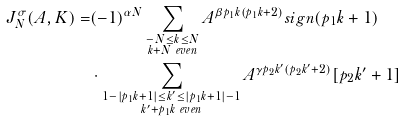Convert formula to latex. <formula><loc_0><loc_0><loc_500><loc_500>J _ { N } ^ { \sigma } ( A , K ) = & ( - 1 ) ^ { \alpha N } \sum _ { \substack { - N \leq k \leq N \\ k + N \ e v e n } } A ^ { \beta p _ { 1 } k ( p _ { 1 } k + 2 ) } s i g n ( p _ { 1 } k + 1 ) \\ & \cdot \sum _ { \substack { 1 - | p _ { 1 } k + 1 | \leq k ^ { \prime } \leq | p _ { 1 } k + 1 | - 1 \\ k ^ { \prime } + p _ { 1 } k \ e v e n } } A ^ { \gamma p _ { 2 } k ^ { \prime } ( p _ { 2 } k ^ { \prime } + 2 ) } [ p _ { 2 } k ^ { \prime } + 1 ]</formula> 